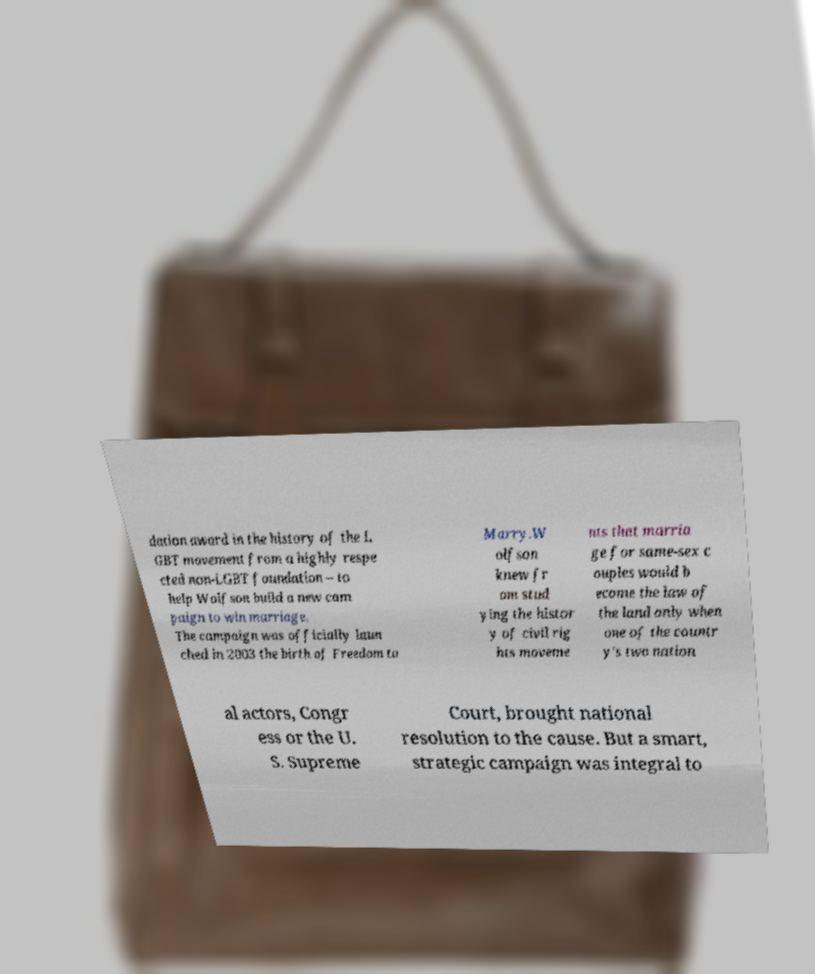What messages or text are displayed in this image? I need them in a readable, typed format. dation award in the history of the L GBT movement from a highly respe cted non-LGBT foundation – to help Wolfson build a new cam paign to win marriage. The campaign was officially laun ched in 2003 the birth of Freedom to Marry.W olfson knew fr om stud ying the histor y of civil rig hts moveme nts that marria ge for same-sex c ouples would b ecome the law of the land only when one of the countr y's two nation al actors, Congr ess or the U. S. Supreme Court, brought national resolution to the cause. But a smart, strategic campaign was integral to 